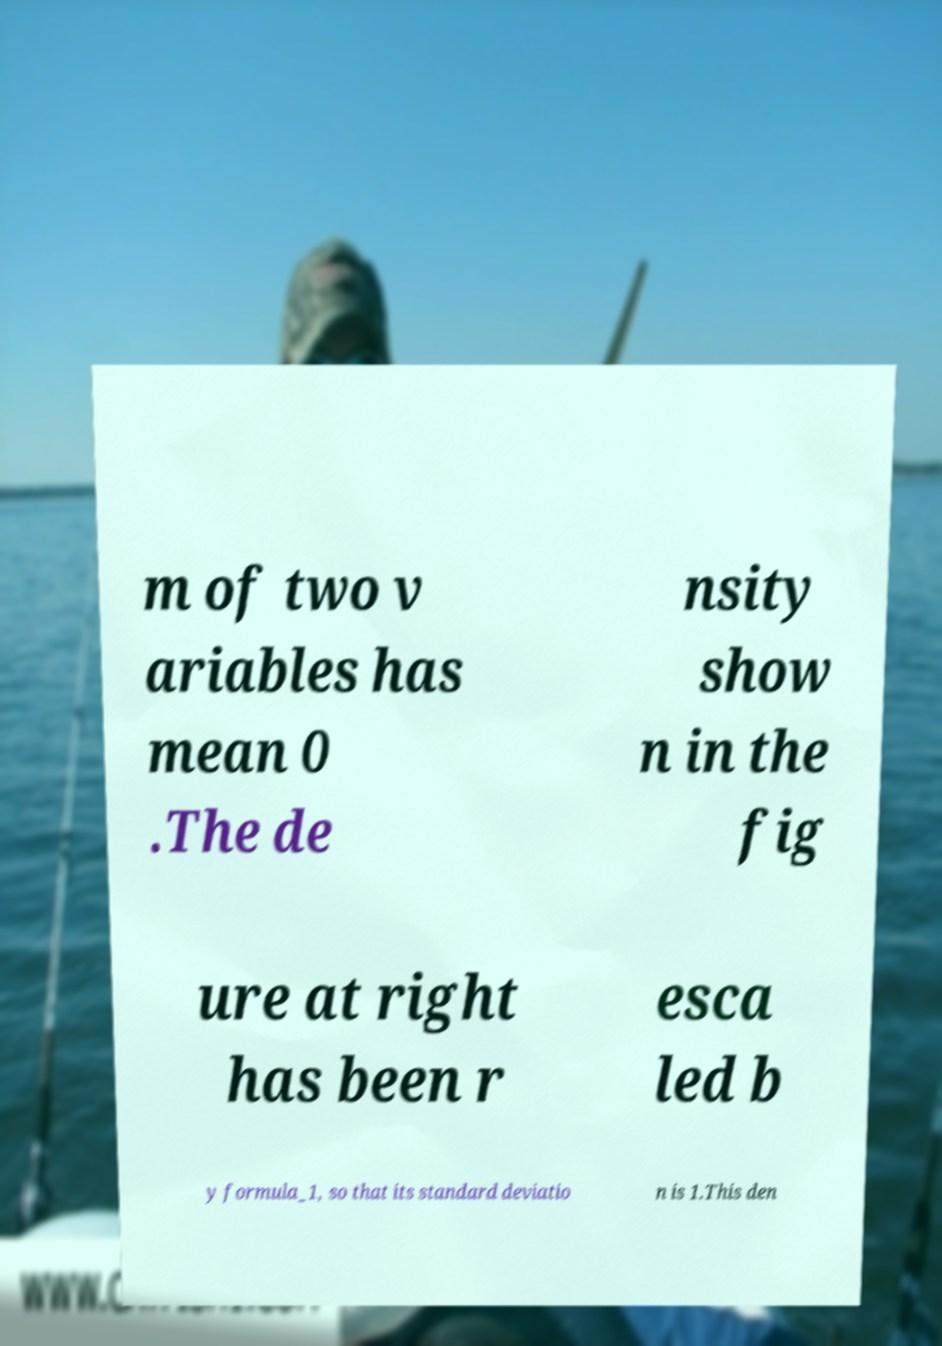Please read and relay the text visible in this image. What does it say? m of two v ariables has mean 0 .The de nsity show n in the fig ure at right has been r esca led b y formula_1, so that its standard deviatio n is 1.This den 